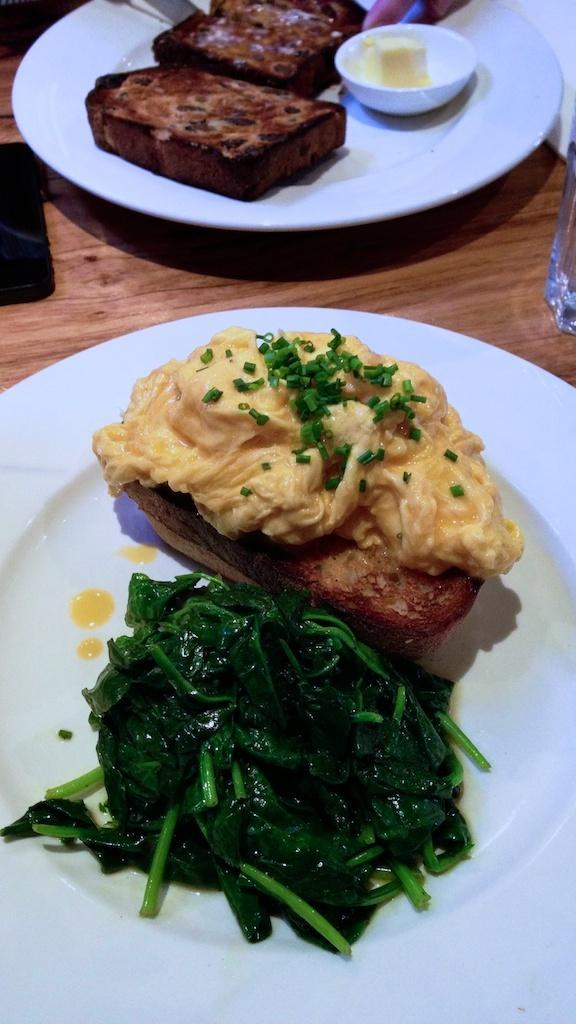What type of furniture is present in the image? There is a table in the image. How many plates are placed on the table? Two plates are placed on the table. What else is placed on the table besides the plates? A glass is placed on the table, along with other objects. What can be seen on the plates? There are different food items on the plates. What type of body is visible in the image? There is no body present in the image; it only features a table, plates, a glass, and other objects. 